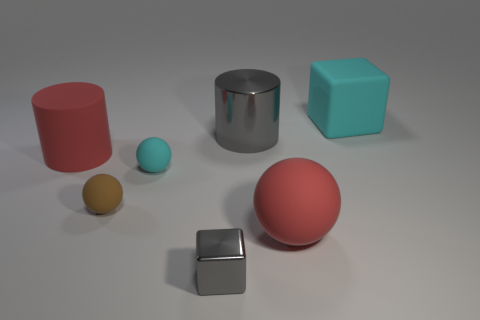What textures are visible in the image, and how do they interact with the light? The surfaces of the objects vary from matte, like the cyan rubber sphere, to shiny, such as the gray metal cube and cylinder. The textures play with the light differently; the matte surfaces reflect diffusely while the shiny ones offer clear reflections, adding visual interest to the scene. 